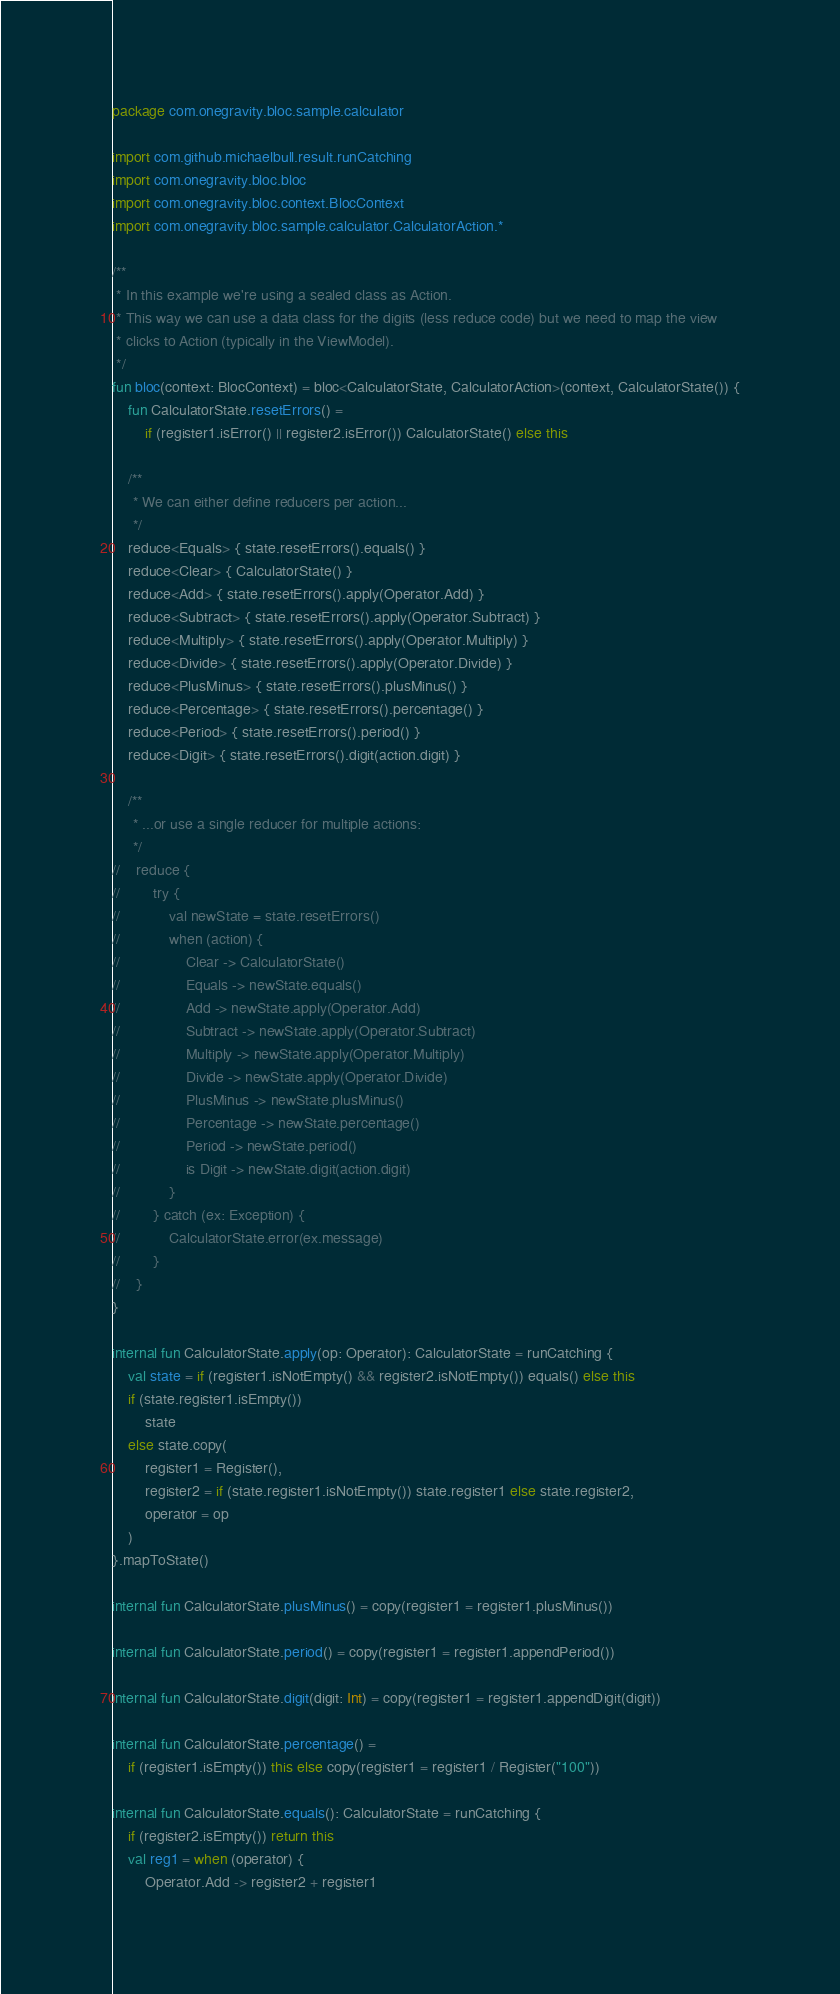<code> <loc_0><loc_0><loc_500><loc_500><_Kotlin_>package com.onegravity.bloc.sample.calculator

import com.github.michaelbull.result.runCatching
import com.onegravity.bloc.bloc
import com.onegravity.bloc.context.BlocContext
import com.onegravity.bloc.sample.calculator.CalculatorAction.*

/**
 * In this example we're using a sealed class as Action.
 * This way we can use a data class for the digits (less reduce code) but we need to map the view
 * clicks to Action (typically in the ViewModel).
 */
fun bloc(context: BlocContext) = bloc<CalculatorState, CalculatorAction>(context, CalculatorState()) {
    fun CalculatorState.resetErrors() =
        if (register1.isError() || register2.isError()) CalculatorState() else this

    /**
     * We can either define reducers per action...
     */
    reduce<Equals> { state.resetErrors().equals() }
    reduce<Clear> { CalculatorState() }
    reduce<Add> { state.resetErrors().apply(Operator.Add) }
    reduce<Subtract> { state.resetErrors().apply(Operator.Subtract) }
    reduce<Multiply> { state.resetErrors().apply(Operator.Multiply) }
    reduce<Divide> { state.resetErrors().apply(Operator.Divide) }
    reduce<PlusMinus> { state.resetErrors().plusMinus() }
    reduce<Percentage> { state.resetErrors().percentage() }
    reduce<Period> { state.resetErrors().period() }
    reduce<Digit> { state.resetErrors().digit(action.digit) }

    /**
     * ...or use a single reducer for multiple actions:
     */
//    reduce {
//        try {
//            val newState = state.resetErrors()
//            when (action) {
//                Clear -> CalculatorState()
//                Equals -> newState.equals()
//                Add -> newState.apply(Operator.Add)
//                Subtract -> newState.apply(Operator.Subtract)
//                Multiply -> newState.apply(Operator.Multiply)
//                Divide -> newState.apply(Operator.Divide)
//                PlusMinus -> newState.plusMinus()
//                Percentage -> newState.percentage()
//                Period -> newState.period()
//                is Digit -> newState.digit(action.digit)
//            }
//        } catch (ex: Exception) {
//            CalculatorState.error(ex.message)
//        }
//    }
}

internal fun CalculatorState.apply(op: Operator): CalculatorState = runCatching {
    val state = if (register1.isNotEmpty() && register2.isNotEmpty()) equals() else this
    if (state.register1.isEmpty())
        state
    else state.copy(
        register1 = Register(),
        register2 = if (state.register1.isNotEmpty()) state.register1 else state.register2,
        operator = op
    )
}.mapToState()

internal fun CalculatorState.plusMinus() = copy(register1 = register1.plusMinus())

internal fun CalculatorState.period() = copy(register1 = register1.appendPeriod())

internal fun CalculatorState.digit(digit: Int) = copy(register1 = register1.appendDigit(digit))

internal fun CalculatorState.percentage() =
    if (register1.isEmpty()) this else copy(register1 = register1 / Register("100"))

internal fun CalculatorState.equals(): CalculatorState = runCatching {
    if (register2.isEmpty()) return this
    val reg1 = when (operator) {
        Operator.Add -> register2 + register1</code> 